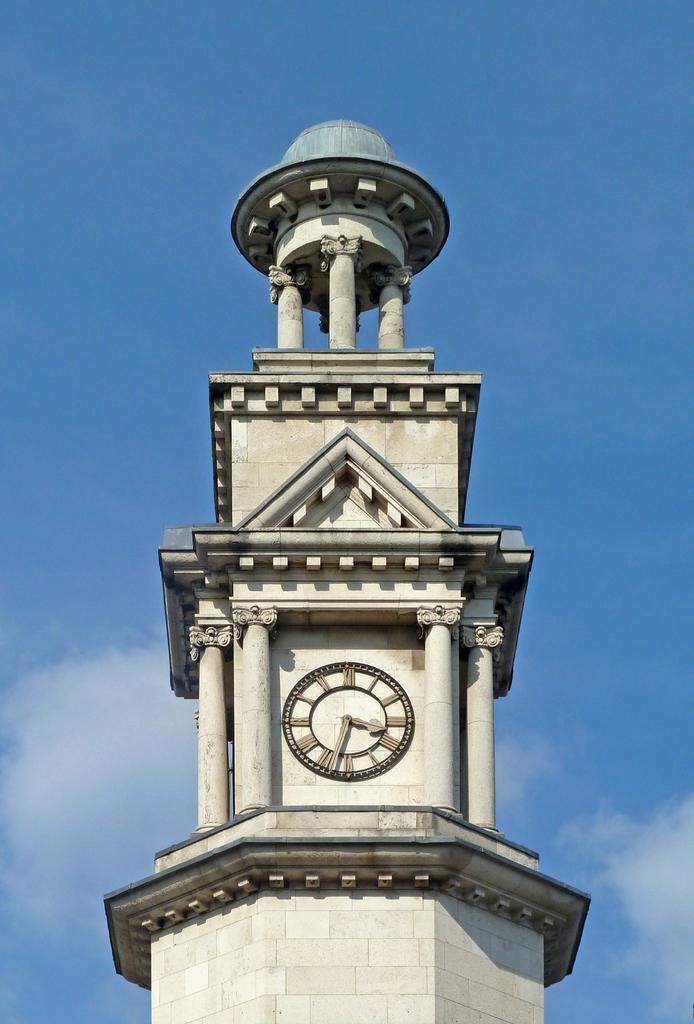<image>
Summarize the visual content of the image. A clock tower with the hands at 3:33 on the face. 